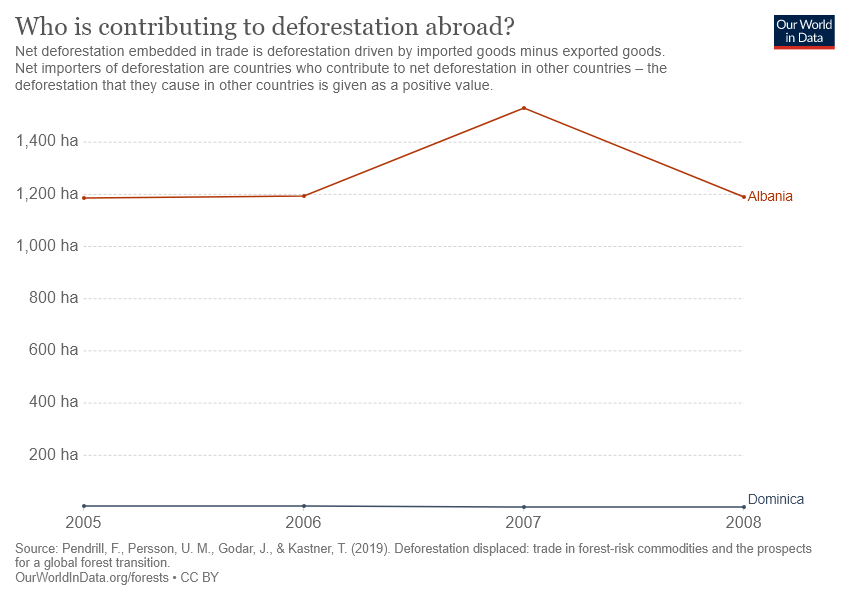Specify some key components in this picture. The chart shows the number of countries represented by the top 100 cryptocurrency exchanges, with 2 being the smallest number of countries and 1,216 being the largest number of countries. The gap between the two countries reaches its peak in 2007. 